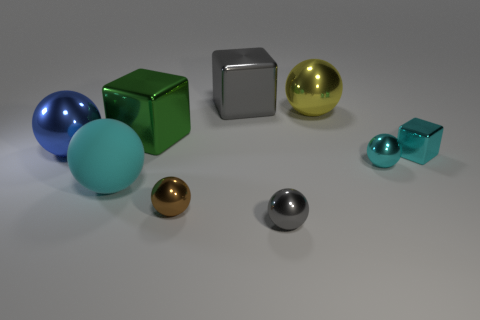What shape is the large matte object that is the same color as the tiny metal cube?
Your answer should be very brief. Sphere. There is a yellow sphere; does it have the same size as the gray shiny thing that is in front of the small cyan block?
Offer a terse response. No. There is a big cyan object that is the same shape as the brown metal thing; what is it made of?
Provide a short and direct response. Rubber. What is the size of the cube that is left of the large block that is behind the large metal sphere that is behind the blue thing?
Offer a very short reply. Large. Is the size of the cyan rubber object the same as the green metallic object?
Ensure brevity in your answer.  Yes. What material is the thing that is behind the big sphere on the right side of the cyan rubber ball?
Your response must be concise. Metal. Does the gray object that is in front of the yellow sphere have the same shape as the blue shiny object in front of the big green object?
Give a very brief answer. Yes. Are there the same number of shiny things on the left side of the big matte object and large yellow shiny spheres?
Offer a very short reply. Yes. There is a blue shiny object that is to the left of the tiny brown sphere; is there a large cyan matte object that is left of it?
Offer a terse response. No. Is there any other thing that has the same color as the small metallic cube?
Provide a succinct answer. Yes. 